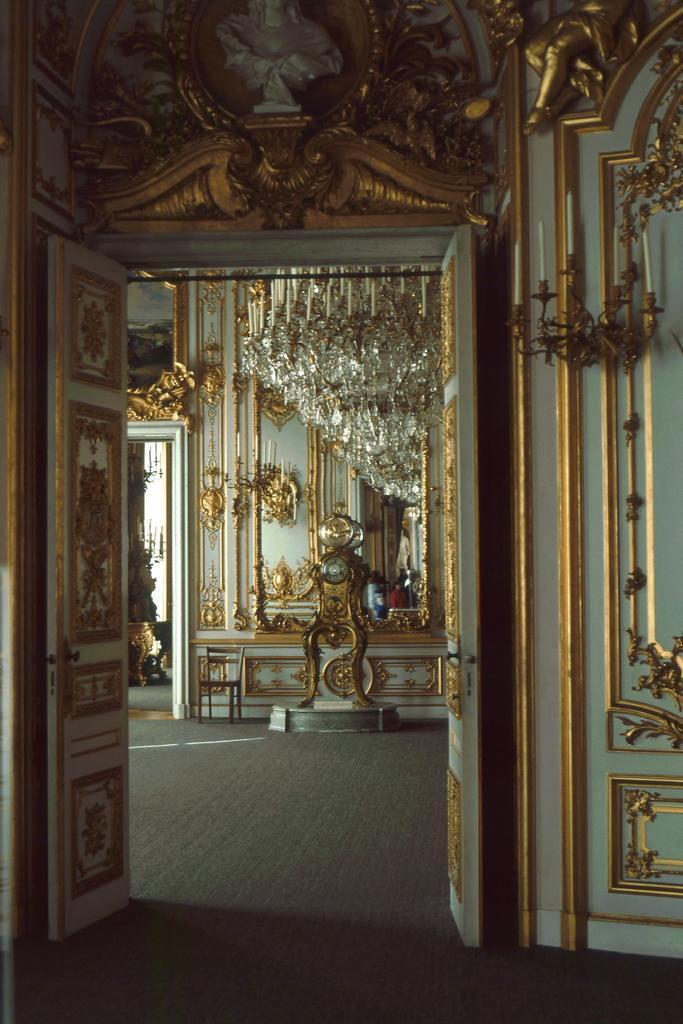In one or two sentences, can you explain what this image depicts? In this picture we can see the designed door, walls and few objects. At the bottom portion of the picture we can see the floor. 